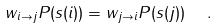<formula> <loc_0><loc_0><loc_500><loc_500>w _ { i \to j } P ( s ( i ) ) = w _ { j \to i } P ( s ( j ) ) \ \ .</formula> 